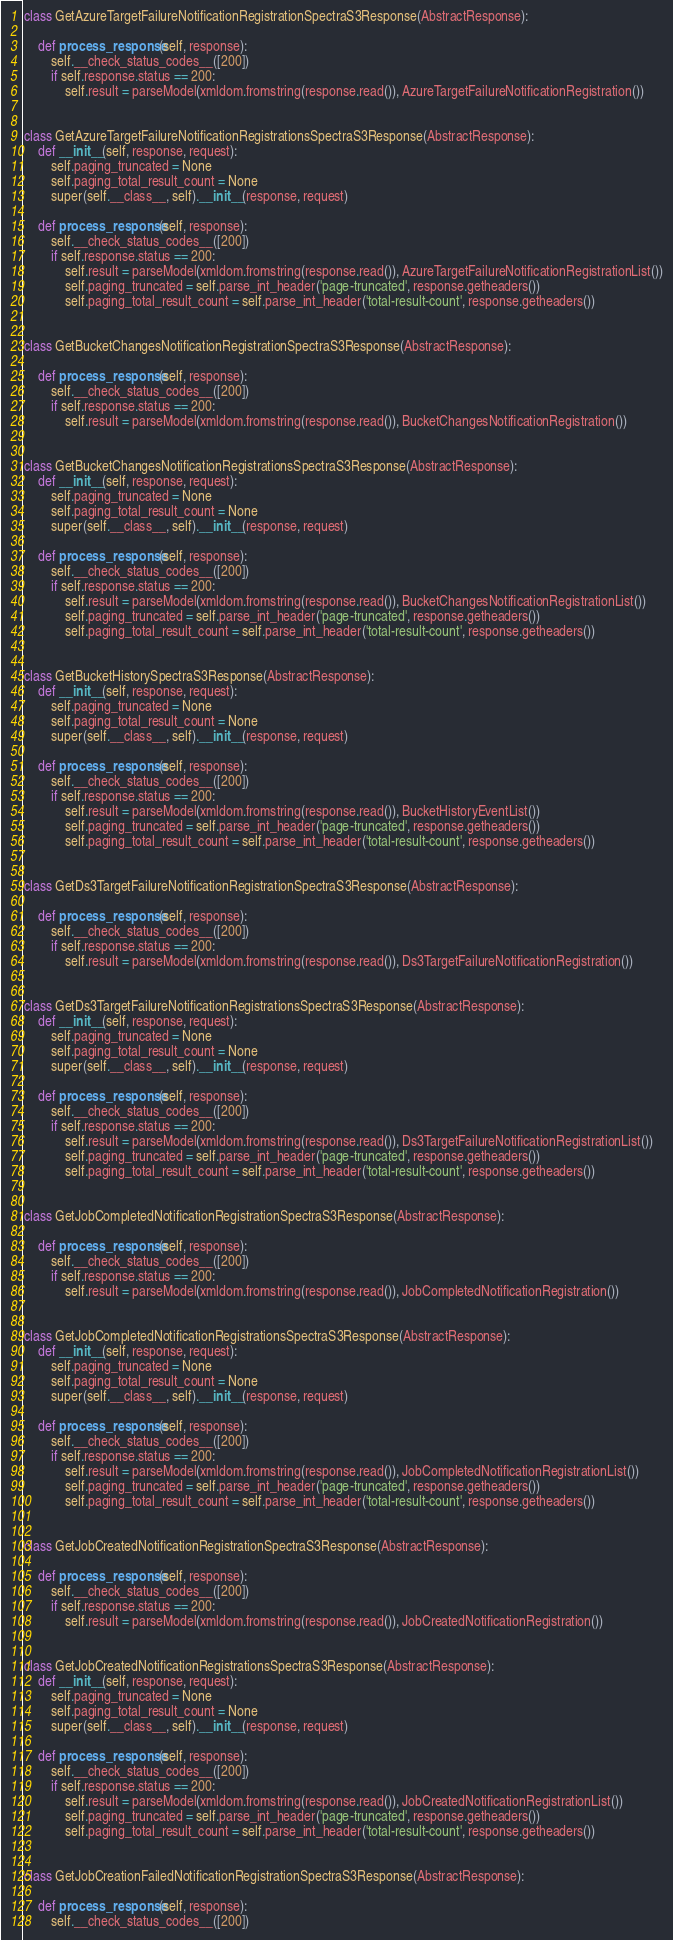<code> <loc_0><loc_0><loc_500><loc_500><_Python_>
class GetAzureTargetFailureNotificationRegistrationSpectraS3Response(AbstractResponse):
    
    def process_response(self, response):
        self.__check_status_codes__([200])
        if self.response.status == 200:
            self.result = parseModel(xmldom.fromstring(response.read()), AzureTargetFailureNotificationRegistration())


class GetAzureTargetFailureNotificationRegistrationsSpectraS3Response(AbstractResponse):
    def __init__(self, response, request):
        self.paging_truncated = None
        self.paging_total_result_count = None
        super(self.__class__, self).__init__(response, request)

    def process_response(self, response):
        self.__check_status_codes__([200])
        if self.response.status == 200:
            self.result = parseModel(xmldom.fromstring(response.read()), AzureTargetFailureNotificationRegistrationList())
            self.paging_truncated = self.parse_int_header('page-truncated', response.getheaders())
            self.paging_total_result_count = self.parse_int_header('total-result-count', response.getheaders())


class GetBucketChangesNotificationRegistrationSpectraS3Response(AbstractResponse):
    
    def process_response(self, response):
        self.__check_status_codes__([200])
        if self.response.status == 200:
            self.result = parseModel(xmldom.fromstring(response.read()), BucketChangesNotificationRegistration())


class GetBucketChangesNotificationRegistrationsSpectraS3Response(AbstractResponse):
    def __init__(self, response, request):
        self.paging_truncated = None
        self.paging_total_result_count = None
        super(self.__class__, self).__init__(response, request)

    def process_response(self, response):
        self.__check_status_codes__([200])
        if self.response.status == 200:
            self.result = parseModel(xmldom.fromstring(response.read()), BucketChangesNotificationRegistrationList())
            self.paging_truncated = self.parse_int_header('page-truncated', response.getheaders())
            self.paging_total_result_count = self.parse_int_header('total-result-count', response.getheaders())


class GetBucketHistorySpectraS3Response(AbstractResponse):
    def __init__(self, response, request):
        self.paging_truncated = None
        self.paging_total_result_count = None
        super(self.__class__, self).__init__(response, request)

    def process_response(self, response):
        self.__check_status_codes__([200])
        if self.response.status == 200:
            self.result = parseModel(xmldom.fromstring(response.read()), BucketHistoryEventList())
            self.paging_truncated = self.parse_int_header('page-truncated', response.getheaders())
            self.paging_total_result_count = self.parse_int_header('total-result-count', response.getheaders())


class GetDs3TargetFailureNotificationRegistrationSpectraS3Response(AbstractResponse):
    
    def process_response(self, response):
        self.__check_status_codes__([200])
        if self.response.status == 200:
            self.result = parseModel(xmldom.fromstring(response.read()), Ds3TargetFailureNotificationRegistration())


class GetDs3TargetFailureNotificationRegistrationsSpectraS3Response(AbstractResponse):
    def __init__(self, response, request):
        self.paging_truncated = None
        self.paging_total_result_count = None
        super(self.__class__, self).__init__(response, request)

    def process_response(self, response):
        self.__check_status_codes__([200])
        if self.response.status == 200:
            self.result = parseModel(xmldom.fromstring(response.read()), Ds3TargetFailureNotificationRegistrationList())
            self.paging_truncated = self.parse_int_header('page-truncated', response.getheaders())
            self.paging_total_result_count = self.parse_int_header('total-result-count', response.getheaders())


class GetJobCompletedNotificationRegistrationSpectraS3Response(AbstractResponse):
    
    def process_response(self, response):
        self.__check_status_codes__([200])
        if self.response.status == 200:
            self.result = parseModel(xmldom.fromstring(response.read()), JobCompletedNotificationRegistration())


class GetJobCompletedNotificationRegistrationsSpectraS3Response(AbstractResponse):
    def __init__(self, response, request):
        self.paging_truncated = None
        self.paging_total_result_count = None
        super(self.__class__, self).__init__(response, request)

    def process_response(self, response):
        self.__check_status_codes__([200])
        if self.response.status == 200:
            self.result = parseModel(xmldom.fromstring(response.read()), JobCompletedNotificationRegistrationList())
            self.paging_truncated = self.parse_int_header('page-truncated', response.getheaders())
            self.paging_total_result_count = self.parse_int_header('total-result-count', response.getheaders())


class GetJobCreatedNotificationRegistrationSpectraS3Response(AbstractResponse):
    
    def process_response(self, response):
        self.__check_status_codes__([200])
        if self.response.status == 200:
            self.result = parseModel(xmldom.fromstring(response.read()), JobCreatedNotificationRegistration())


class GetJobCreatedNotificationRegistrationsSpectraS3Response(AbstractResponse):
    def __init__(self, response, request):
        self.paging_truncated = None
        self.paging_total_result_count = None
        super(self.__class__, self).__init__(response, request)

    def process_response(self, response):
        self.__check_status_codes__([200])
        if self.response.status == 200:
            self.result = parseModel(xmldom.fromstring(response.read()), JobCreatedNotificationRegistrationList())
            self.paging_truncated = self.parse_int_header('page-truncated', response.getheaders())
            self.paging_total_result_count = self.parse_int_header('total-result-count', response.getheaders())


class GetJobCreationFailedNotificationRegistrationSpectraS3Response(AbstractResponse):
    
    def process_response(self, response):
        self.__check_status_codes__([200])</code> 